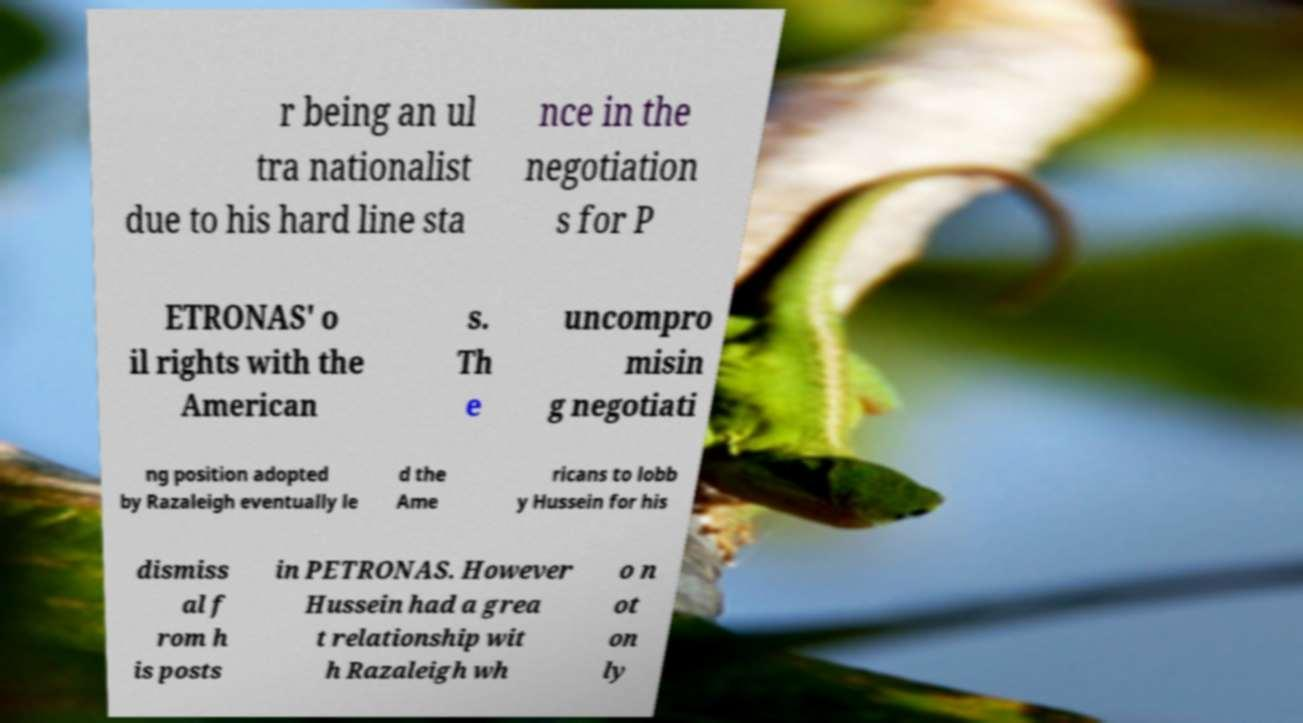What messages or text are displayed in this image? I need them in a readable, typed format. r being an ul tra nationalist due to his hard line sta nce in the negotiation s for P ETRONAS' o il rights with the American s. Th e uncompro misin g negotiati ng position adopted by Razaleigh eventually le d the Ame ricans to lobb y Hussein for his dismiss al f rom h is posts in PETRONAS. However Hussein had a grea t relationship wit h Razaleigh wh o n ot on ly 